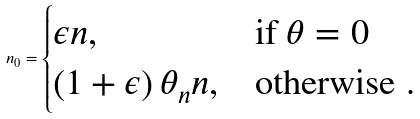<formula> <loc_0><loc_0><loc_500><loc_500>n _ { 0 } = \begin{cases} \epsilon n , & \text {if } \theta = 0 \\ \left ( 1 + \epsilon \right ) \theta _ { n } n , & \text {otherwise } . \end{cases}</formula> 